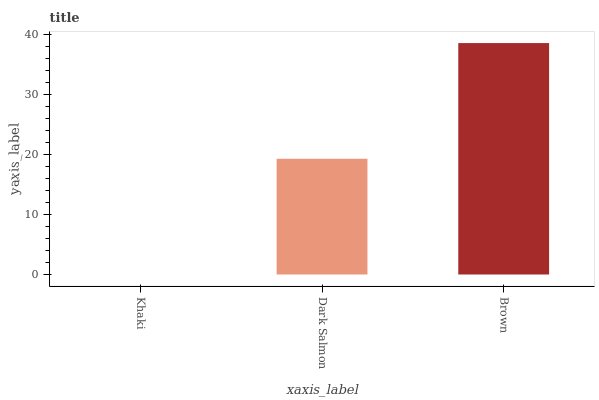Is Khaki the minimum?
Answer yes or no. Yes. Is Brown the maximum?
Answer yes or no. Yes. Is Dark Salmon the minimum?
Answer yes or no. No. Is Dark Salmon the maximum?
Answer yes or no. No. Is Dark Salmon greater than Khaki?
Answer yes or no. Yes. Is Khaki less than Dark Salmon?
Answer yes or no. Yes. Is Khaki greater than Dark Salmon?
Answer yes or no. No. Is Dark Salmon less than Khaki?
Answer yes or no. No. Is Dark Salmon the high median?
Answer yes or no. Yes. Is Dark Salmon the low median?
Answer yes or no. Yes. Is Khaki the high median?
Answer yes or no. No. Is Khaki the low median?
Answer yes or no. No. 